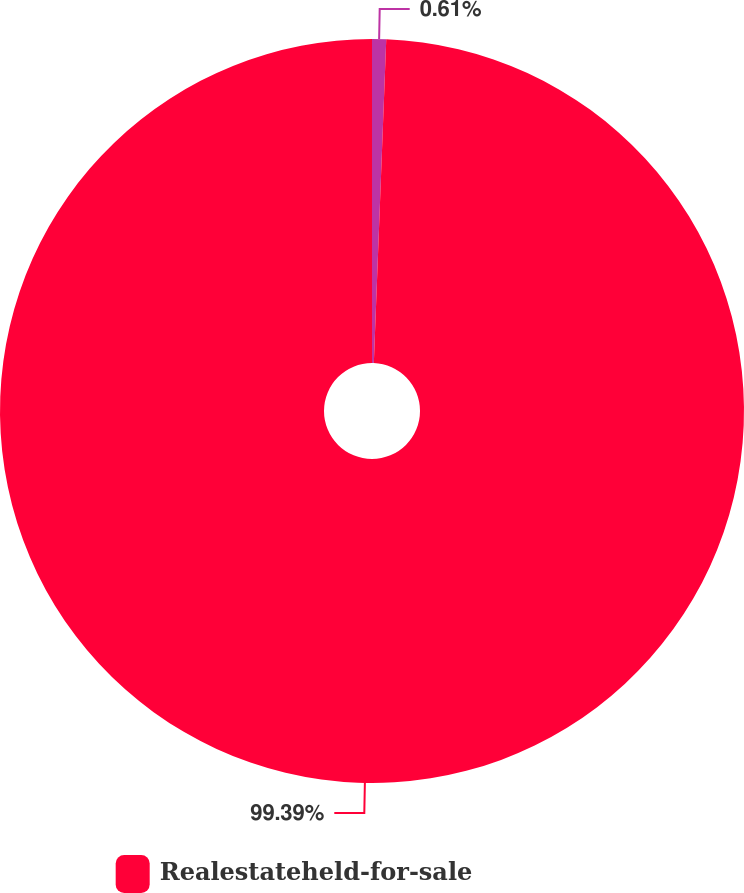<chart> <loc_0><loc_0><loc_500><loc_500><pie_chart><ecel><fcel>Realestateheld-for-sale<nl><fcel>0.61%<fcel>99.39%<nl></chart> 